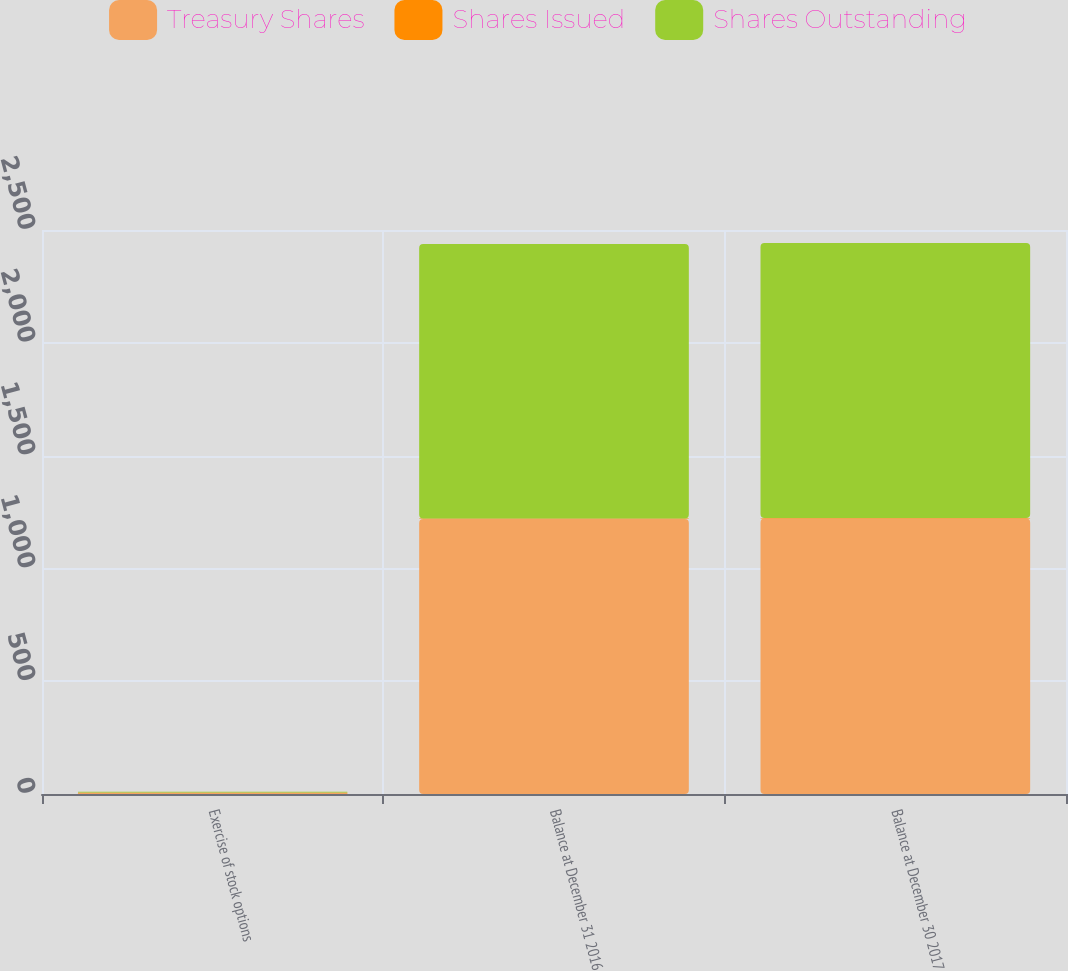<chart> <loc_0><loc_0><loc_500><loc_500><stacked_bar_chart><ecel><fcel>Exercise of stock options<fcel>Balance at December 31 2016<fcel>Balance at December 30 2017<nl><fcel>Treasury Shares<fcel>5<fcel>1219<fcel>1221<nl><fcel>Shares Issued<fcel>2<fcel>2<fcel>2<nl><fcel>Shares Outstanding<fcel>3<fcel>1217<fcel>1219<nl></chart> 